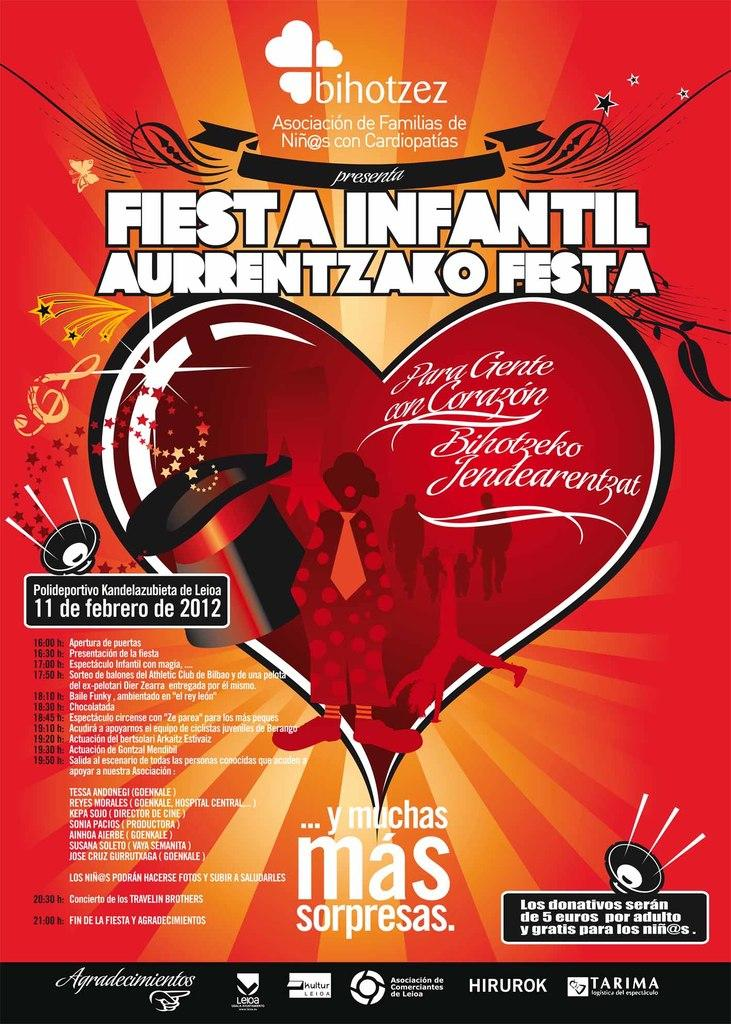<image>
Write a terse but informative summary of the picture. A poster fo fiesta infantil aurrentzako festa with a heart in the center. 